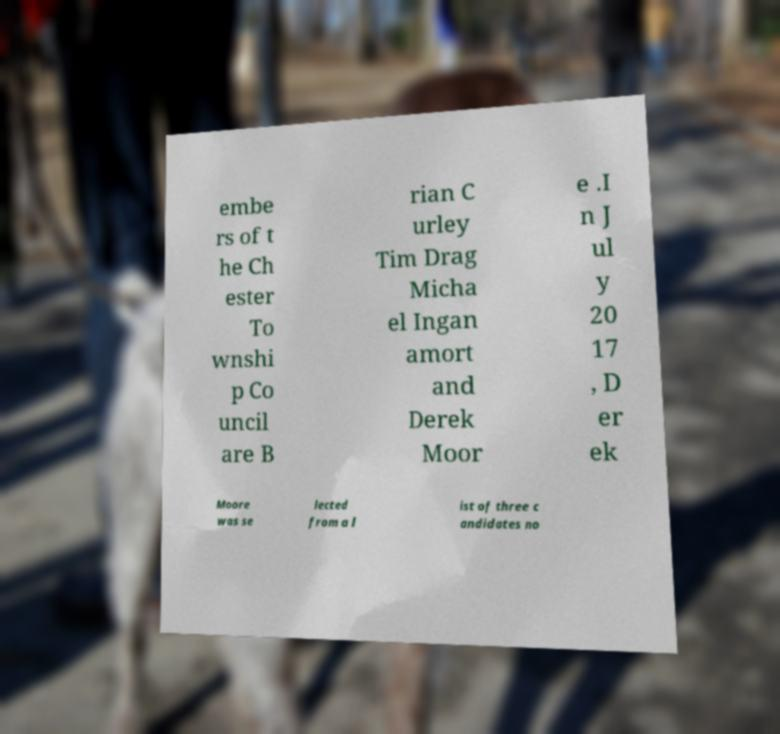Can you accurately transcribe the text from the provided image for me? embe rs of t he Ch ester To wnshi p Co uncil are B rian C urley Tim Drag Micha el Ingan amort and Derek Moor e .I n J ul y 20 17 , D er ek Moore was se lected from a l ist of three c andidates no 